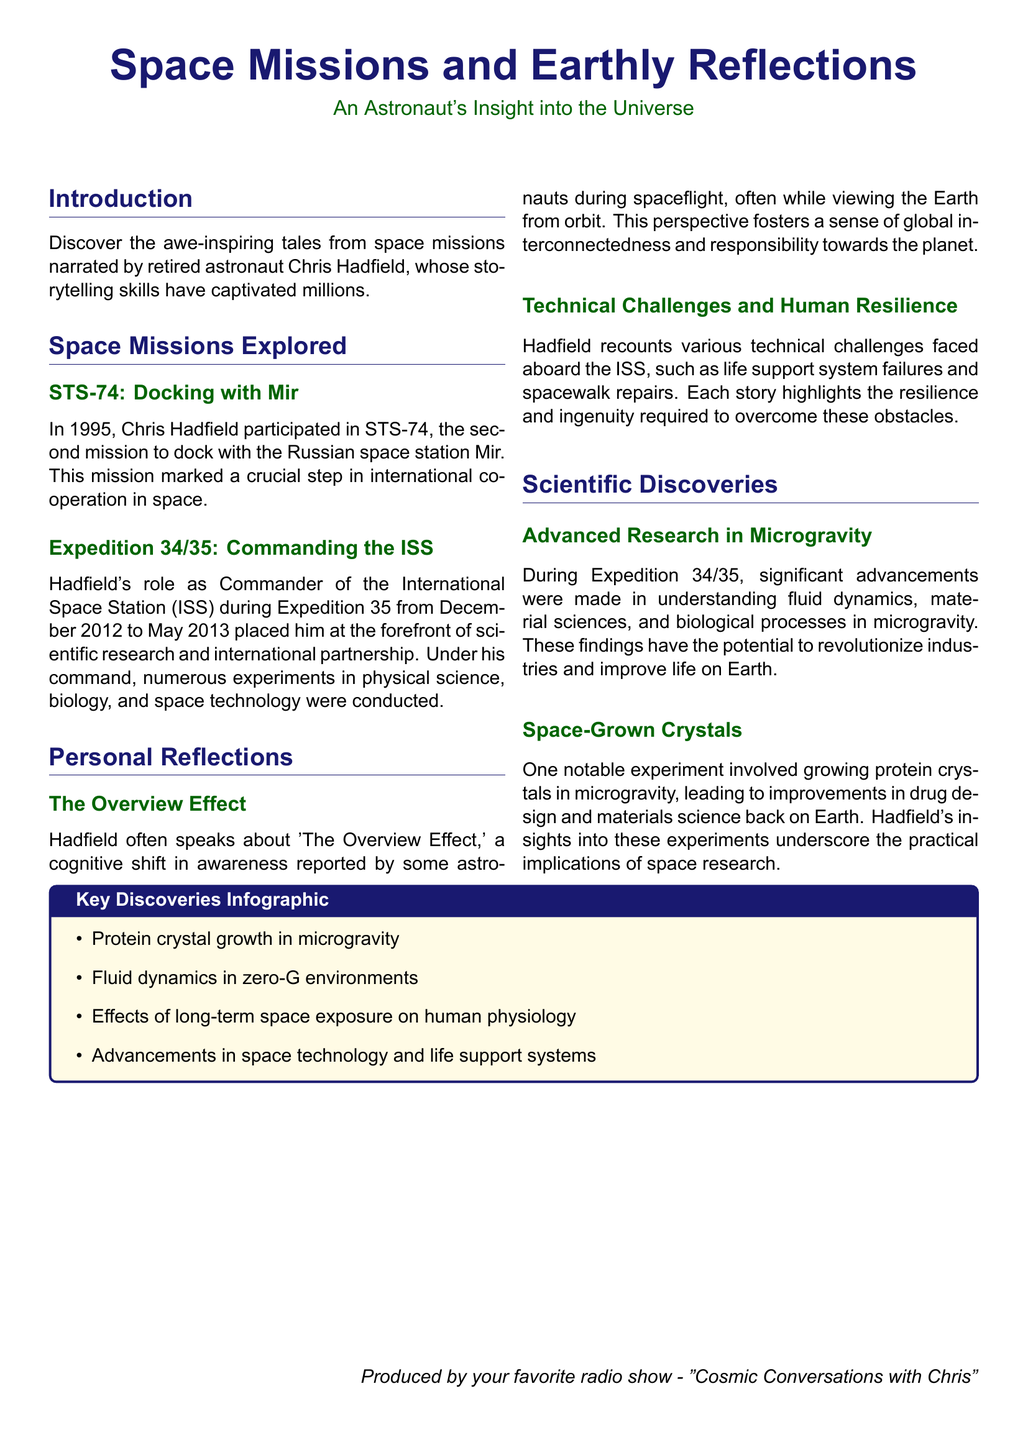What year did STS-74 occur? STS-74, which is discussed in the document, specifically states it took place in 1995.
Answer: 1995 Who commanded the International Space Station during Expedition 35? Expedition 35 mentions Chris Hadfield held the position of Commander during this mission.
Answer: Chris Hadfield What is the primary subject of the "Overview Effect"? The document mentions that the Overview Effect relates to astronauts' cognitive shifts in awareness while viewing Earth, suggesting a connection from this experience.
Answer: Global interconnectedness What notable experiment involved growing crystals in microgravity? The text specifies that protein crystals were grown in microgravity as part of a significant experiment during the Expedition.
Answer: Protein crystals What is one of the scientific advancements made during Expedition 34/35? The document lists various advancements in areas like fluid dynamics and material sciences as significant outcomes of the Expedition.
Answer: Fluid dynamics How many space missions are specifically explored in this document section? The document describes two space missions in detail, namely STS-74 and Expedition 34/35.
Answer: Two What type of challenges does Hadfield recount in his stories about the ISS? The document highlights that Hadfield's stories focus on technical challenges and their solutions aboard the ISS.
Answer: Technical challenges What does the infographic summarize at the end of the document? The key discoveries infographic summarizes significant research findings and advancements from the missions discussed in the document.
Answer: Key discoveries 